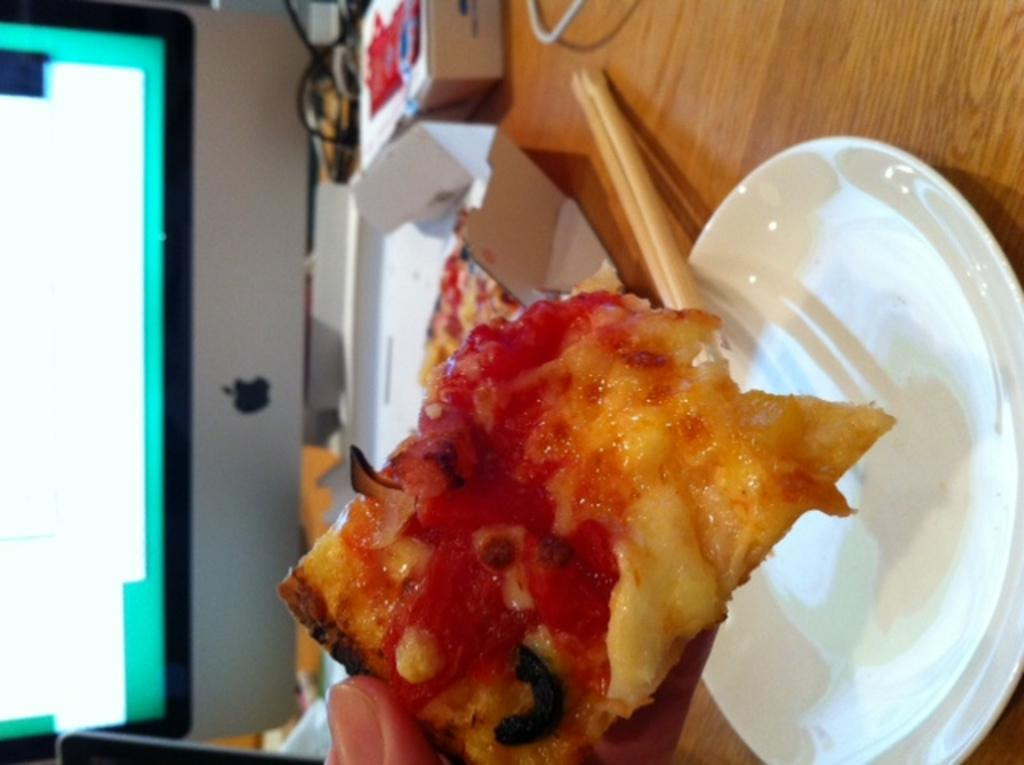What piece of furniture is present in the image? There is a table in the image. What is placed on the table? There is a plate on the table. What is on the plate? There is a food item on the plate. What electronic device is visible in the image? There is a monitor in the image. Can you see any records being played on the monitor in the image? There is no record player or any records visible in the image; only a monitor is present. Is there any grass growing on the table in the image? There is no grass present in the image; the table has a plate with a food item on it. 